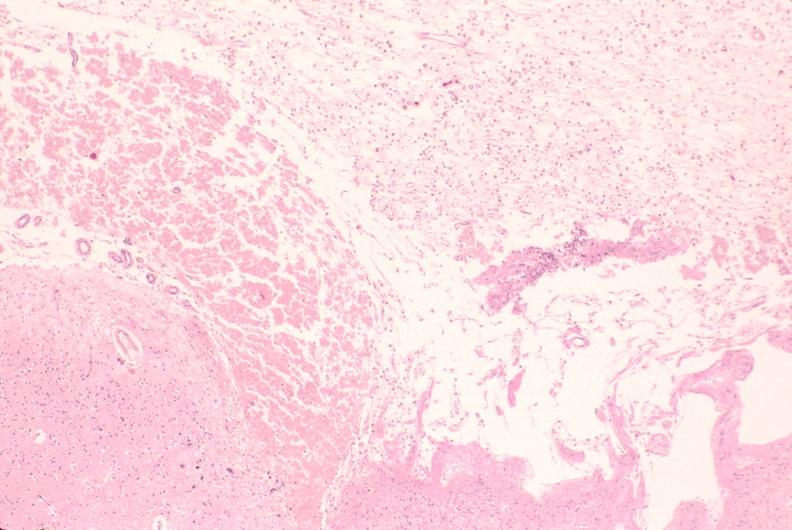does this image show brain, encephalomalasia?
Answer the question using a single word or phrase. Yes 